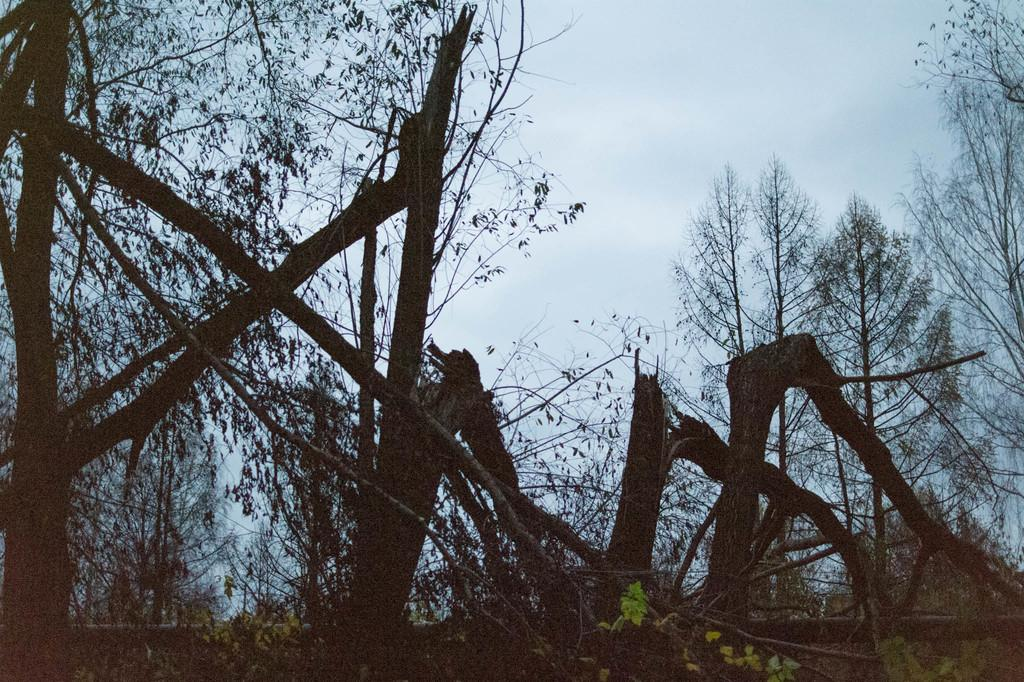What is in the foreground of the picture? There are trees in the foreground of the picture. What is the condition of the trees? The trees appear to be chopped. What can be seen in the background of the picture? The sky is visible in the background of the picture. Reasoning: Let'g: Let's think step by step in order to produce the conversation. We start by identifying the main subject in the foreground of the image, which is the trees. Then, we describe the condition of the trees, noting that they appear to be chopped. Finally, we mention the background of the image, which is the cloudy sky. Absurd Question/Answer: What type of lace can be seen hanging from the trees in the image? There is no lace present in the image; the trees appear to be chopped. What part of the pen is visible in the image? There is no pen present in the image. 